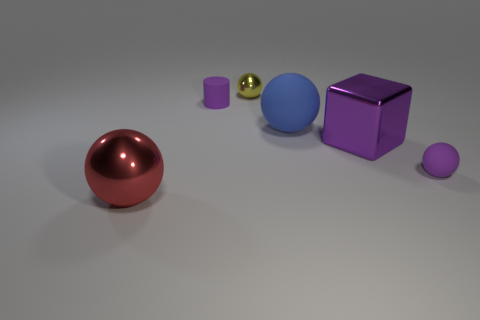What is the material of the purple ball?
Keep it short and to the point. Rubber. Does the tiny cylinder have the same color as the cube?
Make the answer very short. Yes. Is the number of big blue objects that are in front of the big red shiny object less than the number of tiny cyan metallic balls?
Make the answer very short. No. The rubber thing to the left of the yellow metallic thing is what color?
Your answer should be compact. Purple. What is the shape of the large purple metal object?
Make the answer very short. Cube. Are there any purple objects that are in front of the large ball on the right side of the shiny sphere on the left side of the yellow metal object?
Your response must be concise. Yes. There is a small sphere that is to the left of the big shiny thing that is behind the big ball on the left side of the small yellow shiny thing; what is its color?
Offer a terse response. Yellow. What is the material of the other big thing that is the same shape as the big rubber object?
Keep it short and to the point. Metal. What size is the ball that is right of the large sphere to the right of the red metal object?
Make the answer very short. Small. There is a purple object that is in front of the block; what is its material?
Ensure brevity in your answer.  Rubber. 